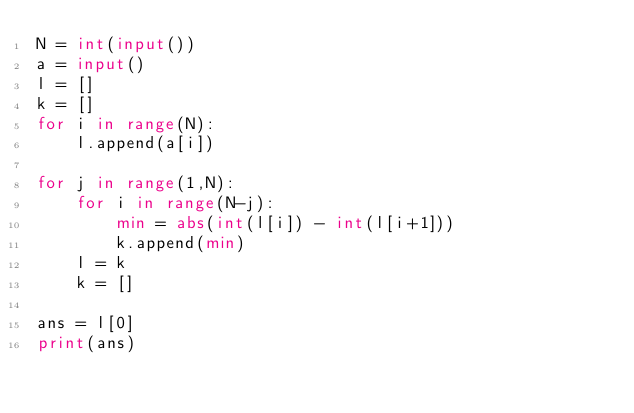<code> <loc_0><loc_0><loc_500><loc_500><_Python_>N = int(input())
a = input()
l = []
k = []
for i in range(N):
    l.append(a[i])

for j in range(1,N):
    for i in range(N-j):
        min = abs(int(l[i]) - int(l[i+1]))
        k.append(min)
    l = k
    k = []
    
ans = l[0]
print(ans)</code> 